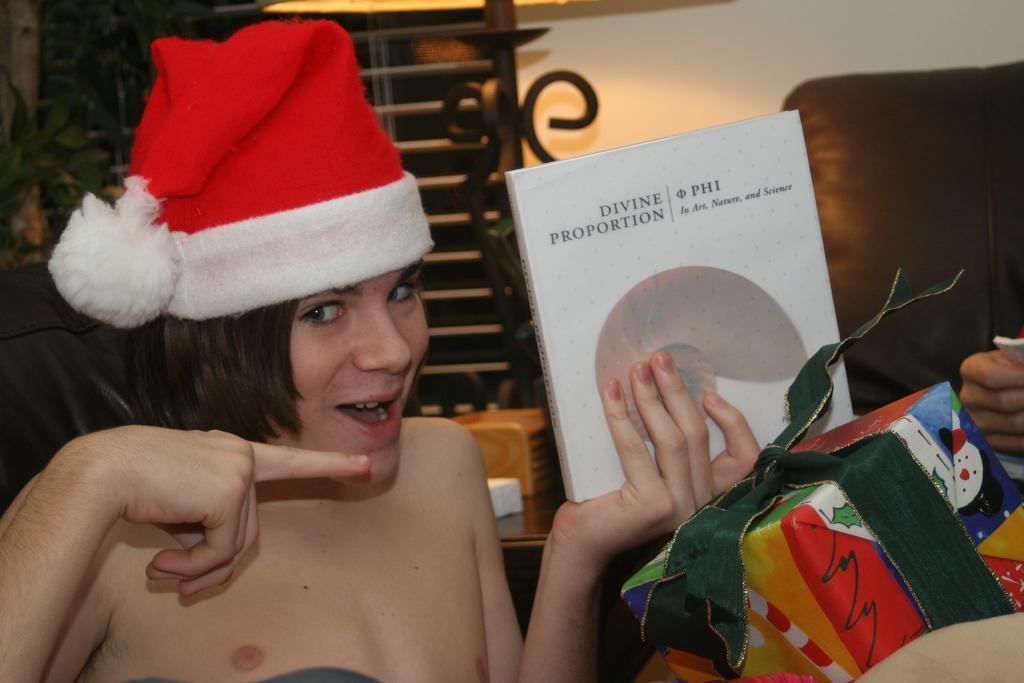How would you summarize this image in a sentence or two? In this image there is a person holding a book in his hands and wearing a hat, on the right side there is a gift pack, in the background there is a sofa, wall and a pole. 